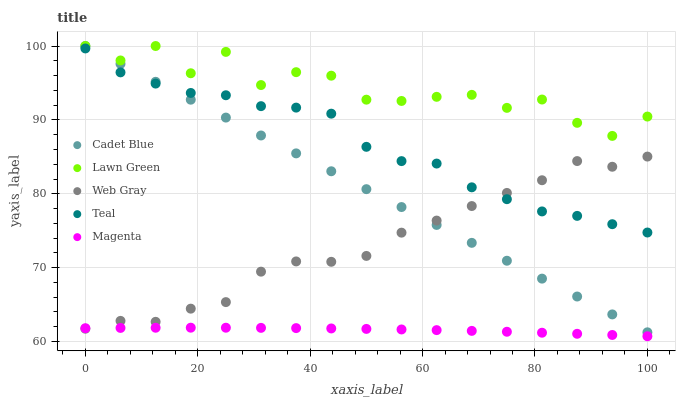Does Magenta have the minimum area under the curve?
Answer yes or no. Yes. Does Lawn Green have the maximum area under the curve?
Answer yes or no. Yes. Does Cadet Blue have the minimum area under the curve?
Answer yes or no. No. Does Cadet Blue have the maximum area under the curve?
Answer yes or no. No. Is Cadet Blue the smoothest?
Answer yes or no. Yes. Is Lawn Green the roughest?
Answer yes or no. Yes. Is Magenta the smoothest?
Answer yes or no. No. Is Magenta the roughest?
Answer yes or no. No. Does Magenta have the lowest value?
Answer yes or no. Yes. Does Cadet Blue have the lowest value?
Answer yes or no. No. Does Cadet Blue have the highest value?
Answer yes or no. Yes. Does Magenta have the highest value?
Answer yes or no. No. Is Web Gray less than Lawn Green?
Answer yes or no. Yes. Is Lawn Green greater than Magenta?
Answer yes or no. Yes. Does Cadet Blue intersect Web Gray?
Answer yes or no. Yes. Is Cadet Blue less than Web Gray?
Answer yes or no. No. Is Cadet Blue greater than Web Gray?
Answer yes or no. No. Does Web Gray intersect Lawn Green?
Answer yes or no. No. 